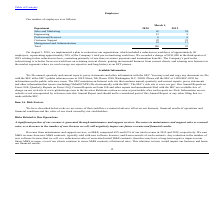According to Globalscape's financial document, Why did the company restructure their organisation? The Company’s goal in the restructuring is to better focus our workforce on retaining current clients, gaining incremental business from current clients, and winning new business in the market segments where we can leverage our expertise and long history as an EFT pioneer.. The document states: "-time severance payments and termination benefits. The Company’s goal in the restructuring is to better focus our workforce on retaining current clien..." Also, Why was there a charge of $381,000 to the company in 2018? We recorded a charge of $381,000 in the third quarter of 2018 relating to this reduction in force, consisting primarily of one-time severance payments and termination benefits.. The document states: "f the Company’s total pre-restructuring workforce. We recorded a charge of $381,000 in the third quarter of 2018 relating to this reduction in force, ..." Also, What percentage of the company's pre-restructuring workers were retrenched? approximately 30% of the Company’s total pre-restructuring workforce. The document states: "employees, representing approximately 30% of the Company’s total pre-restructuring workforce. We recorded a charge of $381,000 in the third quarter of..." Also, can you calculate: What percentage change is the number of employees in the Sales and Marketing department from 2019 to 2020? To answer this question, I need to perform calculations using the financial data. The calculation is: (41-38)/38, which equals 7.89 (percentage). This is based on the information: "Sales and Marketing 41 38 Sales and Marketing 41 38..." The key data points involved are: 38, 41. Also, can you calculate: By what percentage did the number of employees in the Engineering department increase from 2019 to 2020? To answer this question, I need to perform calculations using the financial data. The calculation is: (13-9)/9, which equals 44.44 (percentage). This is based on the information: "Engineering 13 9 Engineering 13 9..." The key data points involved are: 13, 9. Also, can you calculate: How much was the company charged approximately for each employee that was dismissed? Based on the calculation: $381,000/40, the result is 9525. This is based on the information: "restructuring workforce. We recorded a charge of $381,000 in the third quarter of 2018 relating to this reduction in force, consisting primarily of one-time ncluded a reduction in workforce of approxi..." The key data points involved are: 381,000, 40. 